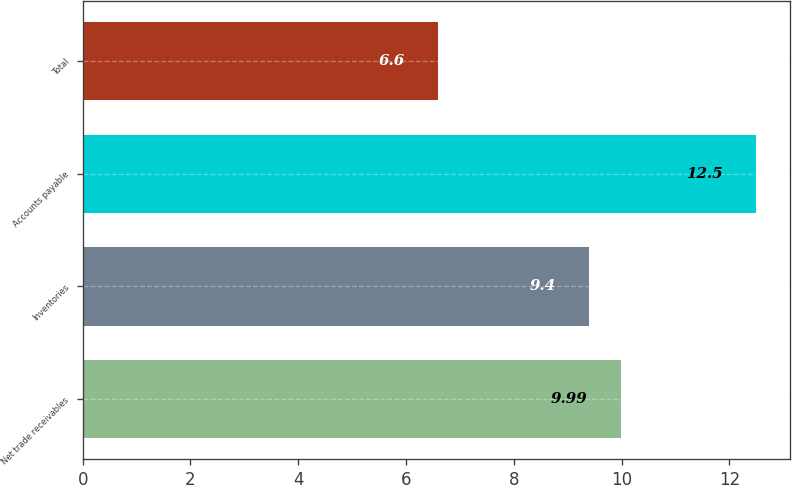Convert chart to OTSL. <chart><loc_0><loc_0><loc_500><loc_500><bar_chart><fcel>Net trade receivables<fcel>Inventories<fcel>Accounts payable<fcel>Total<nl><fcel>9.99<fcel>9.4<fcel>12.5<fcel>6.6<nl></chart> 